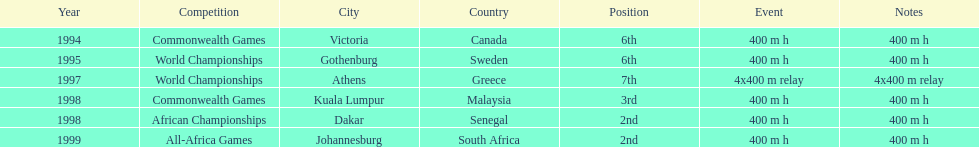What is the total number of competitions on this chart? 6. 